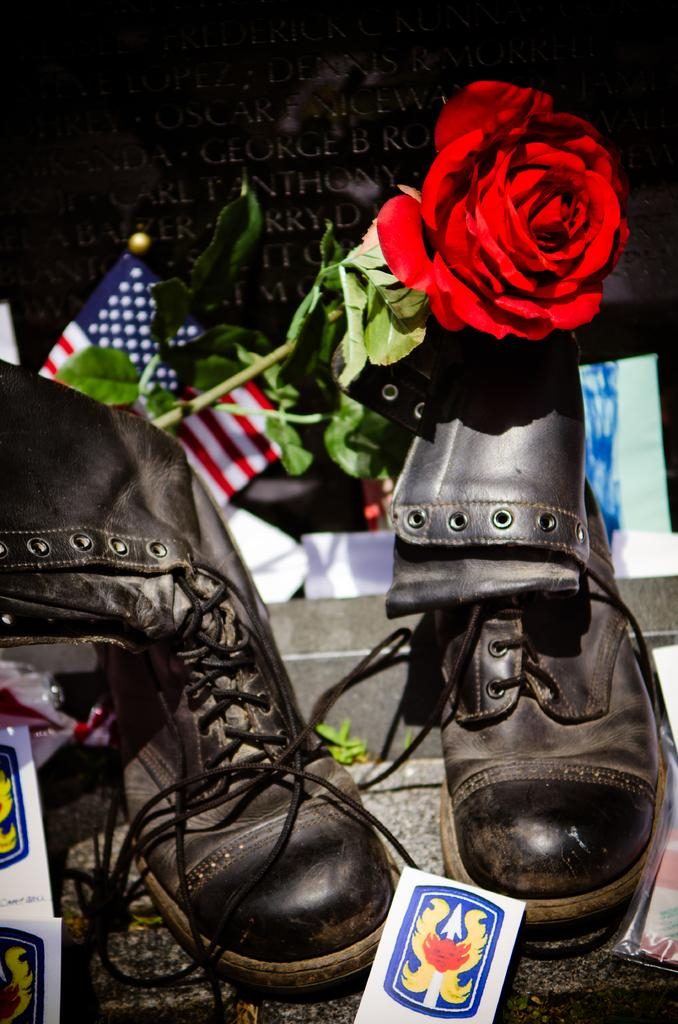What type of footwear is present in the image? There is a pair of shoes in the image. What kind of plant is visible in the image? There is a rose flower with leaves in the image. What is the surface like where the shoes and rose are placed? There is a flat surface in the image. What can be seen in the background of the image? There is some text visible in the background of the image. Can you tell me how many animals are in the zoo in the image? There is no zoo present in the image, so it is not possible to determine how many animals might be there. 